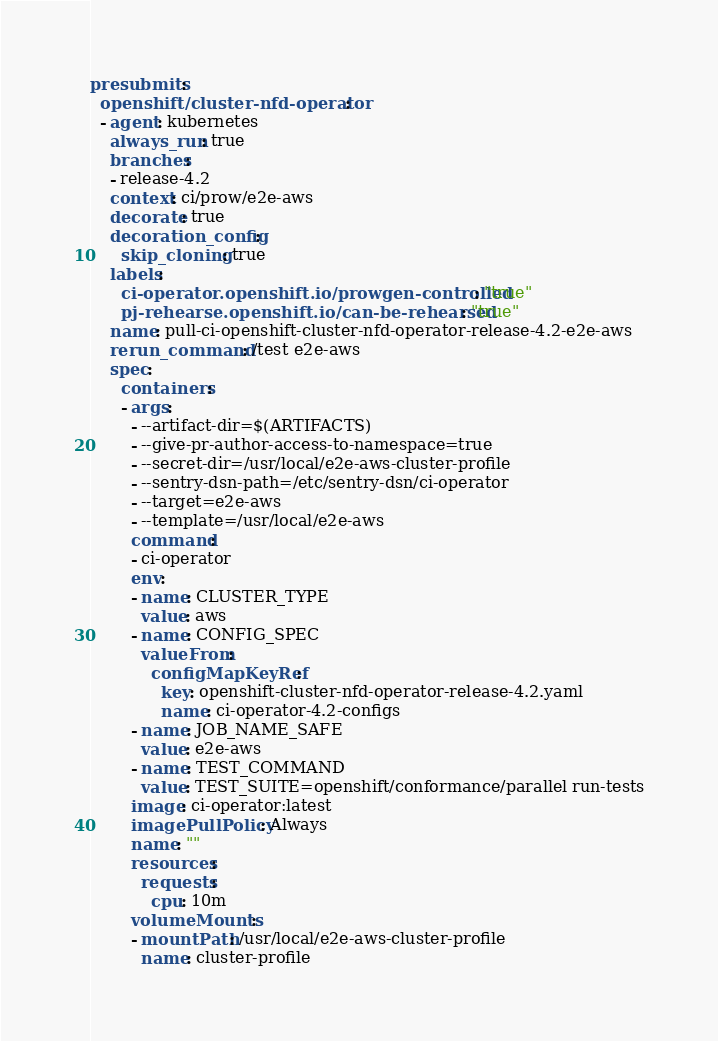<code> <loc_0><loc_0><loc_500><loc_500><_YAML_>presubmits:
  openshift/cluster-nfd-operator:
  - agent: kubernetes
    always_run: true
    branches:
    - release-4.2
    context: ci/prow/e2e-aws
    decorate: true
    decoration_config:
      skip_cloning: true
    labels:
      ci-operator.openshift.io/prowgen-controlled: "true"
      pj-rehearse.openshift.io/can-be-rehearsed: "true"
    name: pull-ci-openshift-cluster-nfd-operator-release-4.2-e2e-aws
    rerun_command: /test e2e-aws
    spec:
      containers:
      - args:
        - --artifact-dir=$(ARTIFACTS)
        - --give-pr-author-access-to-namespace=true
        - --secret-dir=/usr/local/e2e-aws-cluster-profile
        - --sentry-dsn-path=/etc/sentry-dsn/ci-operator
        - --target=e2e-aws
        - --template=/usr/local/e2e-aws
        command:
        - ci-operator
        env:
        - name: CLUSTER_TYPE
          value: aws
        - name: CONFIG_SPEC
          valueFrom:
            configMapKeyRef:
              key: openshift-cluster-nfd-operator-release-4.2.yaml
              name: ci-operator-4.2-configs
        - name: JOB_NAME_SAFE
          value: e2e-aws
        - name: TEST_COMMAND
          value: TEST_SUITE=openshift/conformance/parallel run-tests
        image: ci-operator:latest
        imagePullPolicy: Always
        name: ""
        resources:
          requests:
            cpu: 10m
        volumeMounts:
        - mountPath: /usr/local/e2e-aws-cluster-profile
          name: cluster-profile</code> 